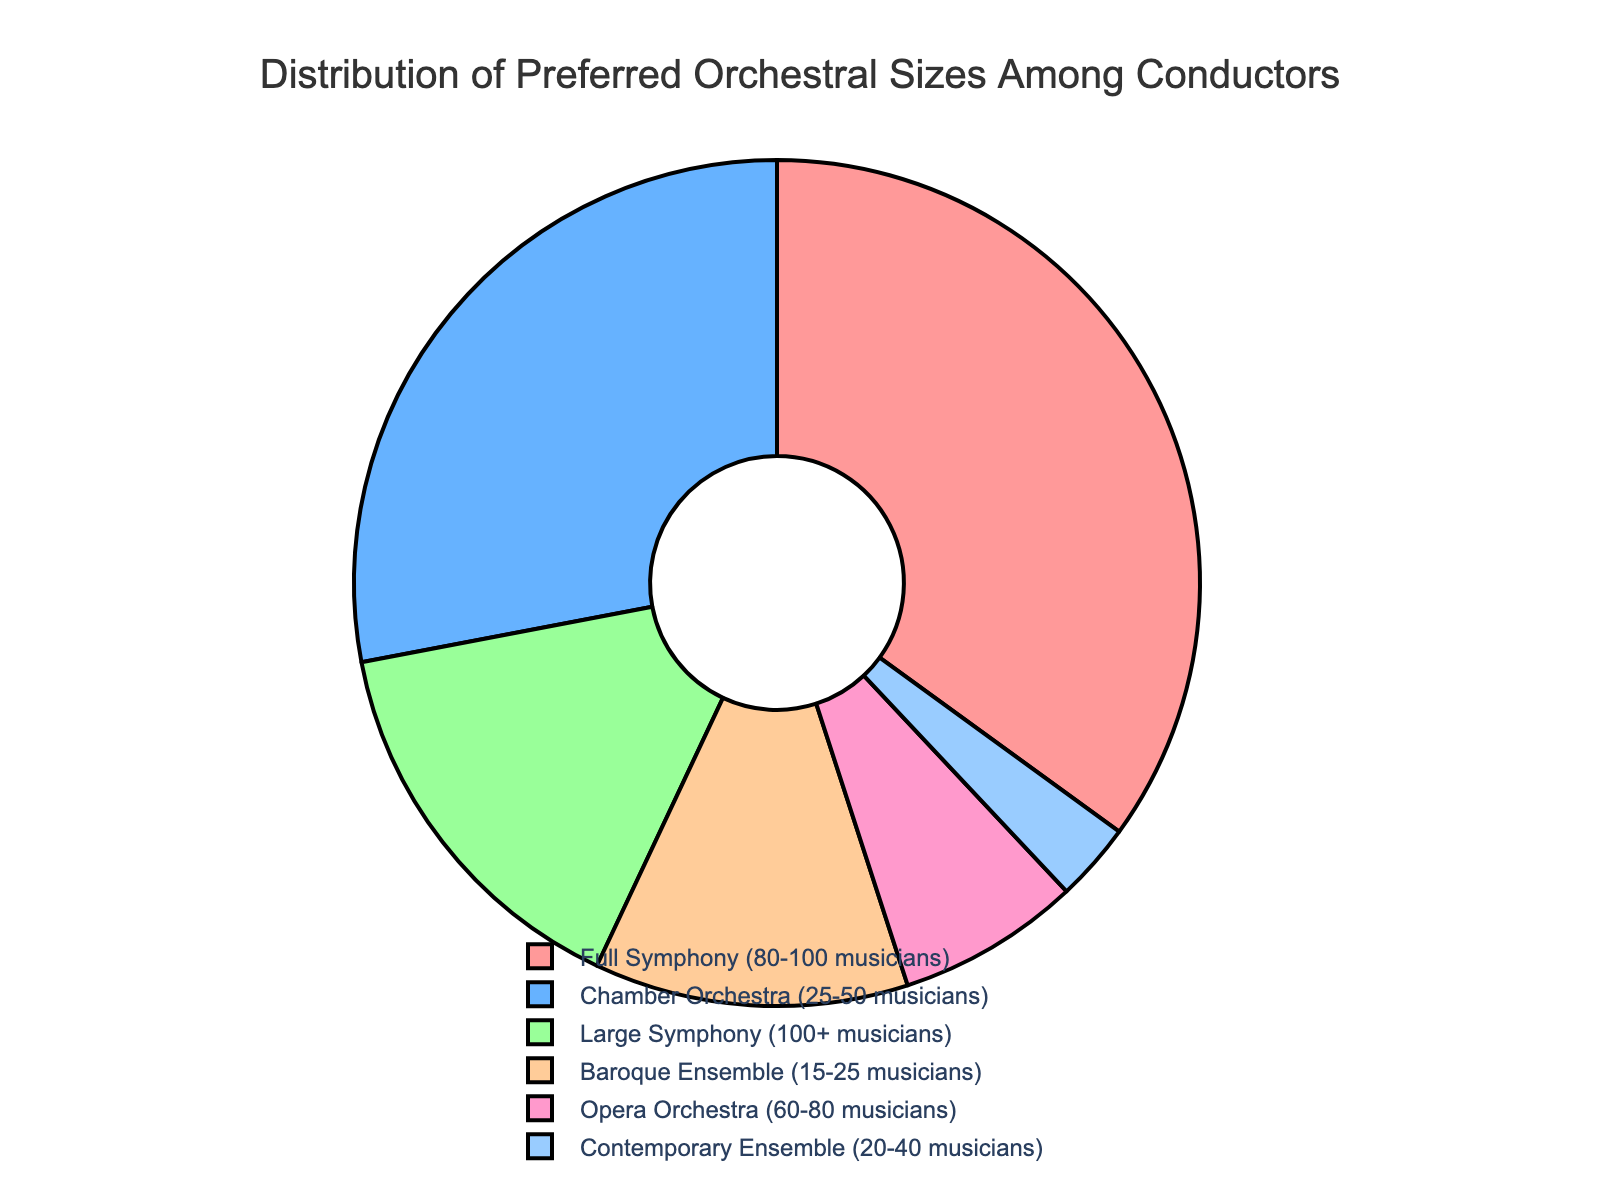Which orchestra size is preferred by the majority of conductors? To determine the majority preference, we look for the category with the highest percentage. "Full Symphony (80-100 musicians)" has 35%, which is the largest percentage.
Answer: Full Symphony (80-100 musicians) What is the combined preference percentage for Chamber Orchestra and Baroque Ensemble? Sum the percentages for "Chamber Orchestra (25-50 musicians)" and "Baroque Ensemble (15-25 musicians)", which are 28% and 12%, respectively. 28% + 12% = 40%
Answer: 40% Are Full Symphony and Chamber Orchestra preferences together more or less than 60%? Add the percentages for "Full Symphony (80-100 musicians)" and "Chamber Orchestra (25-50 musicians)", which are 35% and 28%, respectively. 35% + 28% = 63%, which is more than 60%.
Answer: More Which orchestra size is represented by the pink section? The pink section corresponds to "Full Symphony (80-100 musicians)" in the pie chart.
Answer: Full Symphony (80-100 musicians) Does any orchestra size have a preference below 5%? Examine each section in the pie chart. The smallest percentage is 3% for "Contemporary Ensemble (20-40 musicians)", which is below 5%.
Answer: Yes (Contemporary Ensemble) How much more preferred is the Baroque Ensemble compared to the Contemporary Ensemble? Subtract the percentage for "Contemporary Ensemble (20-40 musicians)" from "Baroque Ensemble (15-25 musicians)". 12% - 3% = 9%
Answer: 9% What percentage of conductors prefer orchestras with fewer than 40 musicians? Sum the percentages for "Chamber Orchestra (25-50 musicians)", "Baroque Ensemble (15-25 musicians)", and "Contemporary Ensemble (20-40 musicians)". 28% + 12% + 3% = 43%
Answer: 43% Which orchestral size is preferred by fewer conductors: Opera Orchestra or Large Symphony? Compare the percentages for "Opera Orchestra (60-80 musicians)" and "Large Symphony (100+ musicians)", which are 7% and 15%, respectively. Opera Orchestra has the fewer preferences.
Answer: Opera Orchestra What is the difference in preference between Full Symphony and Large Symphony orchestras? Subtract the percentage for "Large Symphony (100+ musicians)" from "Full Symphony (80-100 musicians)". 35% - 15% = 20%
Answer: 20% What is the total percentage for orchestral sizes preferred by over 10% of conductors each? Identify and sum the percentages for categories over 10%: "Full Symphony (35%)", "Chamber Orchestra (28%)", and "Baroque Ensemble (12%)". 35% + 28% + 12% = 75%
Answer: 75% 